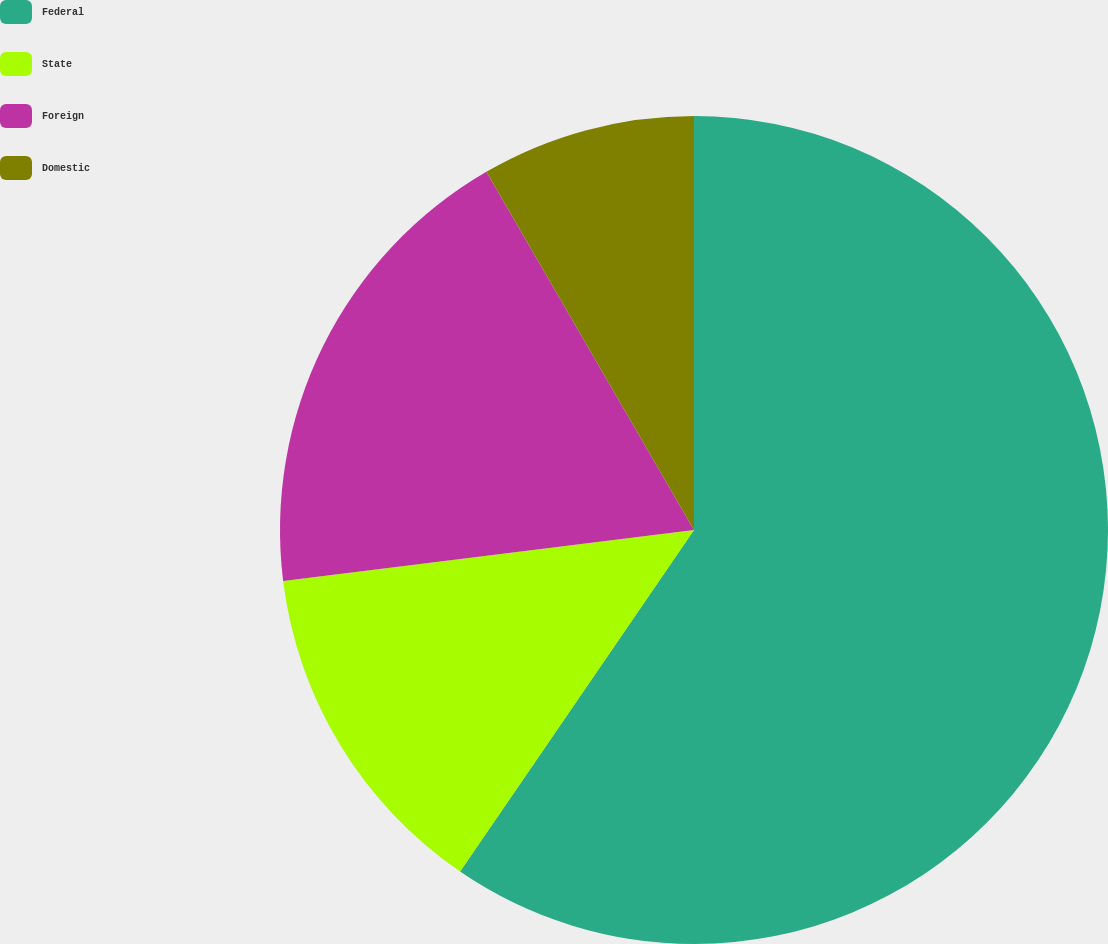Convert chart. <chart><loc_0><loc_0><loc_500><loc_500><pie_chart><fcel>Federal<fcel>State<fcel>Foreign<fcel>Domestic<nl><fcel>59.55%<fcel>13.48%<fcel>18.6%<fcel>8.36%<nl></chart> 